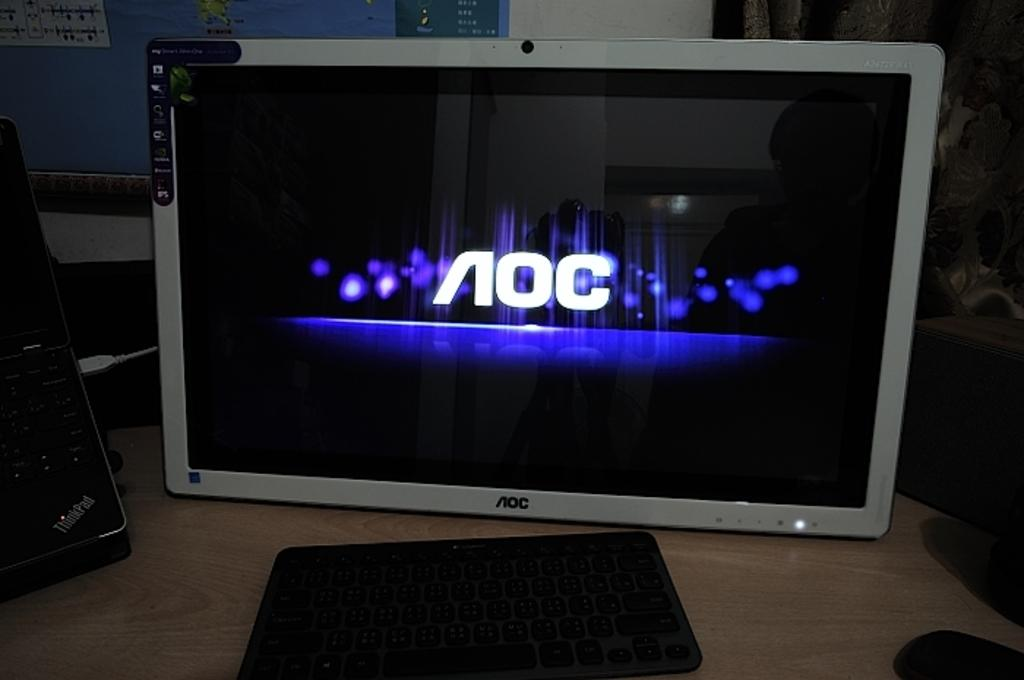<image>
Offer a succinct explanation of the picture presented. An AOC computer monitor is illuminated on a desktop. 